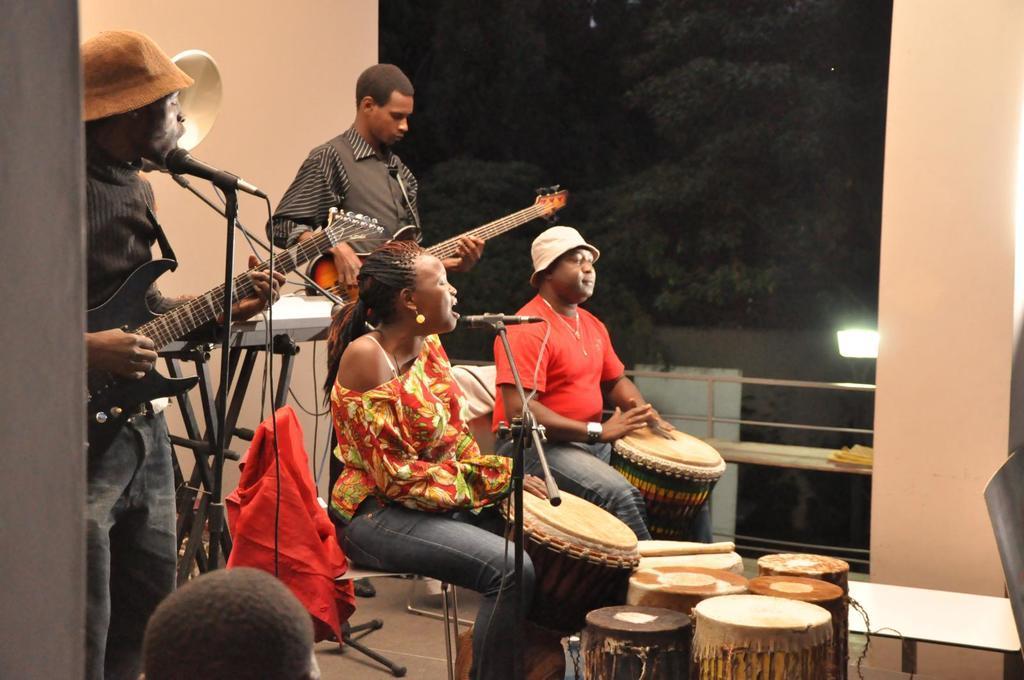Please provide a concise description of this image. there are four persons in which one woman is sitting and playing drums and singing in a micro phone which is in front of her another person is playing drums and sitting,two persons are standing and playing guitar. 